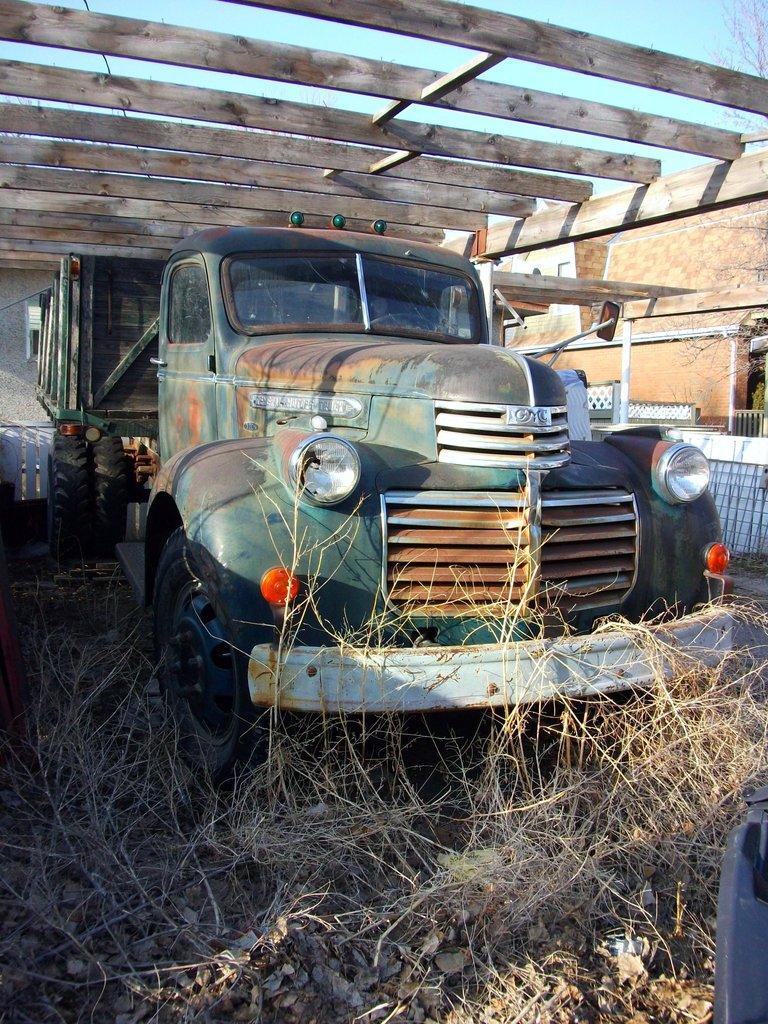Can you describe this image briefly? In the center of the image there is a vehicle on the ground. At the bottom we can see leaves and plants. In the background we can see wooden bars, wall, tree and sky. 